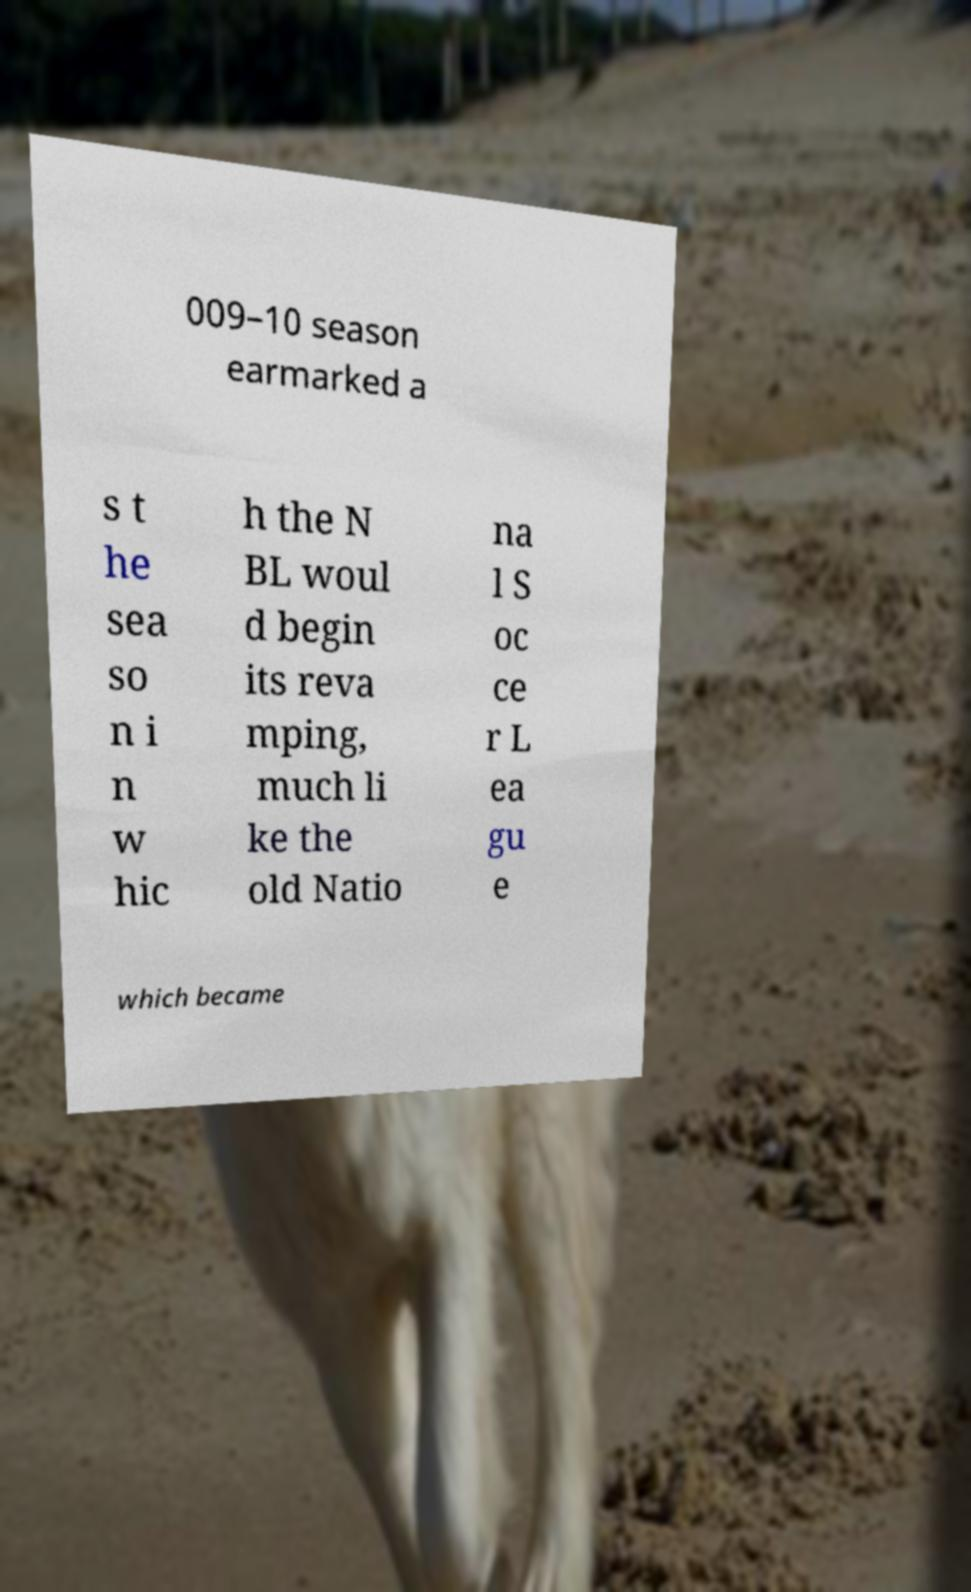Please identify and transcribe the text found in this image. 009–10 season earmarked a s t he sea so n i n w hic h the N BL woul d begin its reva mping, much li ke the old Natio na l S oc ce r L ea gu e which became 